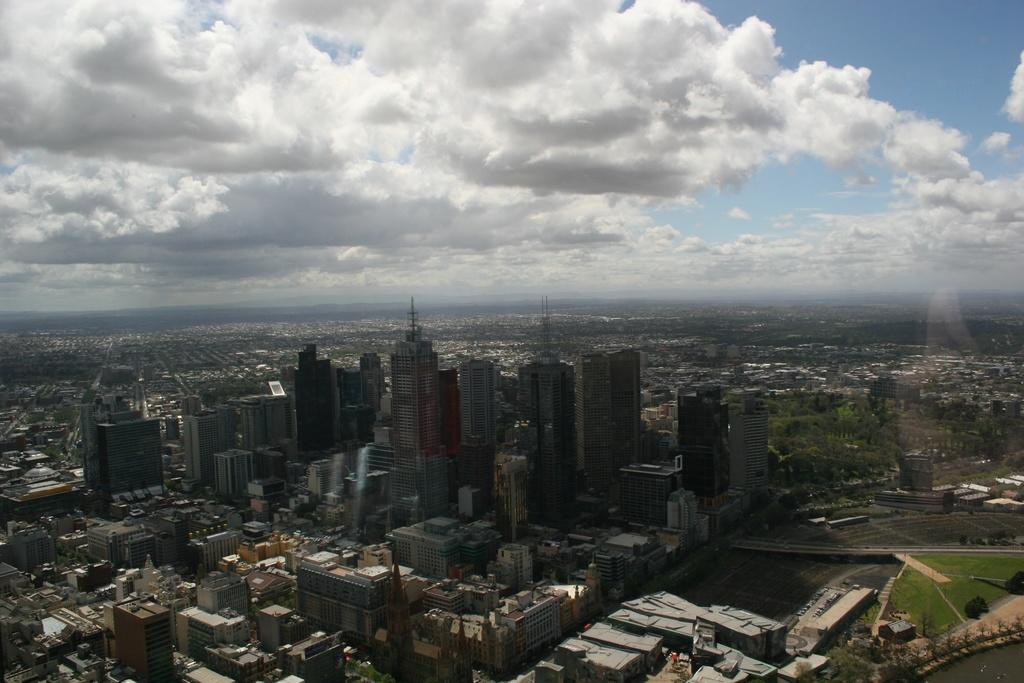What types of structures can be seen in the image? There are multiple buildings in the image. What other natural elements are present in the image? There are trees in the image. What can be seen in the background of the image? There are clouds and the sky visible in the background of the image. What type of crack is visible on the surface of the clouds in the image? There is no crack visible on the surface of the clouds in the image, as clouds do not have a surface or texture like solid objects. 